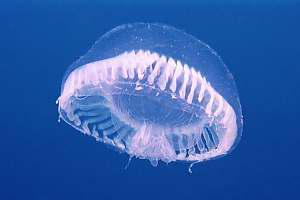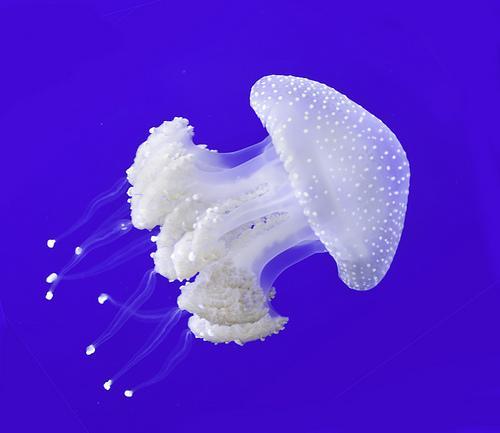The first image is the image on the left, the second image is the image on the right. Analyze the images presented: Is the assertion "The jellyfish in the left and right images are generally the same color, and no single image contains more than two jellyfish." valid? Answer yes or no. Yes. 